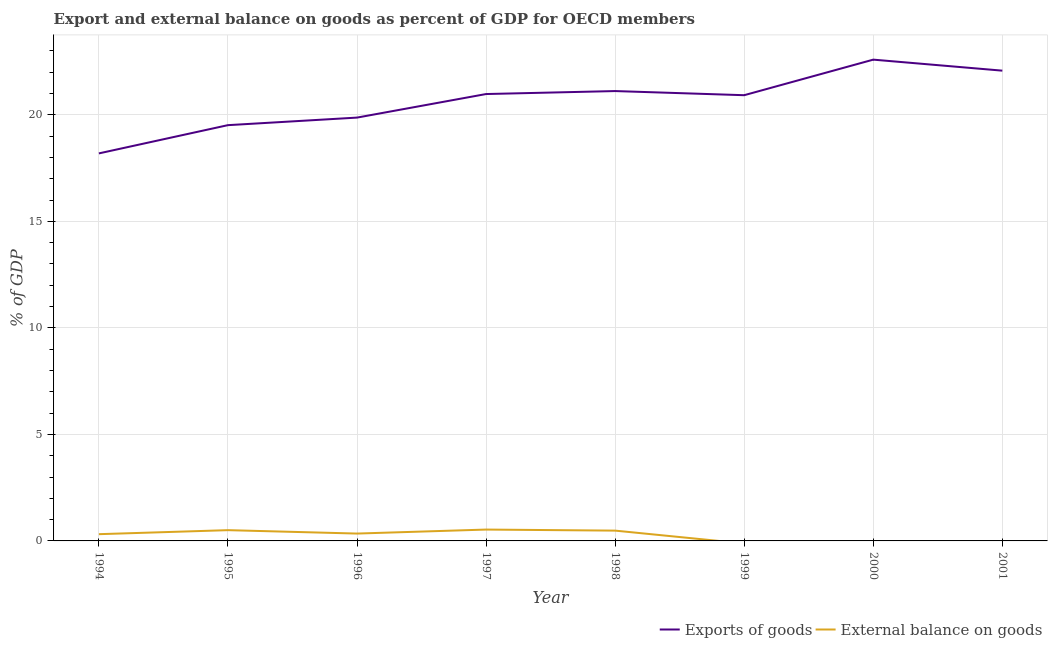What is the export of goods as percentage of gdp in 1997?
Your answer should be compact. 20.98. Across all years, what is the maximum external balance on goods as percentage of gdp?
Keep it short and to the point. 0.53. Across all years, what is the minimum external balance on goods as percentage of gdp?
Ensure brevity in your answer.  0. What is the total external balance on goods as percentage of gdp in the graph?
Offer a terse response. 2.18. What is the difference between the external balance on goods as percentage of gdp in 1996 and that in 1997?
Ensure brevity in your answer.  -0.19. What is the difference between the external balance on goods as percentage of gdp in 1994 and the export of goods as percentage of gdp in 1997?
Your response must be concise. -20.66. What is the average export of goods as percentage of gdp per year?
Make the answer very short. 20.66. In the year 1997, what is the difference between the external balance on goods as percentage of gdp and export of goods as percentage of gdp?
Provide a succinct answer. -20.45. What is the ratio of the export of goods as percentage of gdp in 1998 to that in 2001?
Offer a very short reply. 0.96. What is the difference between the highest and the second highest export of goods as percentage of gdp?
Ensure brevity in your answer.  0.52. What is the difference between the highest and the lowest export of goods as percentage of gdp?
Give a very brief answer. 4.4. Is the sum of the export of goods as percentage of gdp in 1994 and 2001 greater than the maximum external balance on goods as percentage of gdp across all years?
Offer a very short reply. Yes. How many lines are there?
Your answer should be compact. 2. Are the values on the major ticks of Y-axis written in scientific E-notation?
Your answer should be very brief. No. Does the graph contain any zero values?
Your response must be concise. Yes. Where does the legend appear in the graph?
Offer a terse response. Bottom right. How many legend labels are there?
Offer a terse response. 2. How are the legend labels stacked?
Give a very brief answer. Horizontal. What is the title of the graph?
Offer a very short reply. Export and external balance on goods as percent of GDP for OECD members. What is the label or title of the Y-axis?
Your response must be concise. % of GDP. What is the % of GDP in Exports of goods in 1994?
Give a very brief answer. 18.19. What is the % of GDP of External balance on goods in 1994?
Your answer should be compact. 0.32. What is the % of GDP in Exports of goods in 1995?
Your answer should be very brief. 19.52. What is the % of GDP in External balance on goods in 1995?
Give a very brief answer. 0.51. What is the % of GDP of Exports of goods in 1996?
Your answer should be compact. 19.87. What is the % of GDP in External balance on goods in 1996?
Offer a terse response. 0.35. What is the % of GDP of Exports of goods in 1997?
Your answer should be compact. 20.98. What is the % of GDP of External balance on goods in 1997?
Provide a short and direct response. 0.53. What is the % of GDP of Exports of goods in 1998?
Give a very brief answer. 21.12. What is the % of GDP in External balance on goods in 1998?
Your answer should be very brief. 0.48. What is the % of GDP of Exports of goods in 1999?
Provide a succinct answer. 20.92. What is the % of GDP of Exports of goods in 2000?
Your answer should be compact. 22.59. What is the % of GDP of Exports of goods in 2001?
Your response must be concise. 22.08. What is the % of GDP in External balance on goods in 2001?
Provide a succinct answer. 0. Across all years, what is the maximum % of GDP of Exports of goods?
Your answer should be very brief. 22.59. Across all years, what is the maximum % of GDP of External balance on goods?
Offer a terse response. 0.53. Across all years, what is the minimum % of GDP in Exports of goods?
Make the answer very short. 18.19. What is the total % of GDP of Exports of goods in the graph?
Your response must be concise. 165.27. What is the total % of GDP in External balance on goods in the graph?
Your answer should be very brief. 2.18. What is the difference between the % of GDP of Exports of goods in 1994 and that in 1995?
Provide a short and direct response. -1.33. What is the difference between the % of GDP in External balance on goods in 1994 and that in 1995?
Ensure brevity in your answer.  -0.19. What is the difference between the % of GDP of Exports of goods in 1994 and that in 1996?
Provide a succinct answer. -1.68. What is the difference between the % of GDP of External balance on goods in 1994 and that in 1996?
Your answer should be very brief. -0.03. What is the difference between the % of GDP in Exports of goods in 1994 and that in 1997?
Ensure brevity in your answer.  -2.79. What is the difference between the % of GDP in External balance on goods in 1994 and that in 1997?
Give a very brief answer. -0.22. What is the difference between the % of GDP of Exports of goods in 1994 and that in 1998?
Offer a very short reply. -2.93. What is the difference between the % of GDP in External balance on goods in 1994 and that in 1998?
Your response must be concise. -0.17. What is the difference between the % of GDP of Exports of goods in 1994 and that in 1999?
Provide a short and direct response. -2.73. What is the difference between the % of GDP of Exports of goods in 1994 and that in 2000?
Offer a very short reply. -4.4. What is the difference between the % of GDP of Exports of goods in 1994 and that in 2001?
Make the answer very short. -3.88. What is the difference between the % of GDP in Exports of goods in 1995 and that in 1996?
Make the answer very short. -0.35. What is the difference between the % of GDP of External balance on goods in 1995 and that in 1996?
Your response must be concise. 0.16. What is the difference between the % of GDP in Exports of goods in 1995 and that in 1997?
Your response must be concise. -1.46. What is the difference between the % of GDP in External balance on goods in 1995 and that in 1997?
Keep it short and to the point. -0.03. What is the difference between the % of GDP in Exports of goods in 1995 and that in 1998?
Your response must be concise. -1.6. What is the difference between the % of GDP of External balance on goods in 1995 and that in 1998?
Offer a very short reply. 0.02. What is the difference between the % of GDP in Exports of goods in 1995 and that in 1999?
Provide a succinct answer. -1.41. What is the difference between the % of GDP of Exports of goods in 1995 and that in 2000?
Your answer should be compact. -3.08. What is the difference between the % of GDP of Exports of goods in 1995 and that in 2001?
Give a very brief answer. -2.56. What is the difference between the % of GDP in Exports of goods in 1996 and that in 1997?
Offer a terse response. -1.11. What is the difference between the % of GDP of External balance on goods in 1996 and that in 1997?
Your answer should be very brief. -0.19. What is the difference between the % of GDP of Exports of goods in 1996 and that in 1998?
Provide a succinct answer. -1.25. What is the difference between the % of GDP of External balance on goods in 1996 and that in 1998?
Your answer should be very brief. -0.14. What is the difference between the % of GDP of Exports of goods in 1996 and that in 1999?
Your response must be concise. -1.05. What is the difference between the % of GDP of Exports of goods in 1996 and that in 2000?
Offer a very short reply. -2.72. What is the difference between the % of GDP of Exports of goods in 1996 and that in 2001?
Give a very brief answer. -2.2. What is the difference between the % of GDP of Exports of goods in 1997 and that in 1998?
Your response must be concise. -0.14. What is the difference between the % of GDP of External balance on goods in 1997 and that in 1998?
Your response must be concise. 0.05. What is the difference between the % of GDP in Exports of goods in 1997 and that in 1999?
Offer a very short reply. 0.05. What is the difference between the % of GDP of Exports of goods in 1997 and that in 2000?
Offer a very short reply. -1.61. What is the difference between the % of GDP of Exports of goods in 1997 and that in 2001?
Your response must be concise. -1.1. What is the difference between the % of GDP of Exports of goods in 1998 and that in 1999?
Ensure brevity in your answer.  0.19. What is the difference between the % of GDP of Exports of goods in 1998 and that in 2000?
Offer a very short reply. -1.47. What is the difference between the % of GDP of Exports of goods in 1998 and that in 2001?
Your answer should be very brief. -0.96. What is the difference between the % of GDP in Exports of goods in 1999 and that in 2000?
Ensure brevity in your answer.  -1.67. What is the difference between the % of GDP of Exports of goods in 1999 and that in 2001?
Offer a terse response. -1.15. What is the difference between the % of GDP of Exports of goods in 2000 and that in 2001?
Your answer should be very brief. 0.52. What is the difference between the % of GDP in Exports of goods in 1994 and the % of GDP in External balance on goods in 1995?
Your response must be concise. 17.69. What is the difference between the % of GDP of Exports of goods in 1994 and the % of GDP of External balance on goods in 1996?
Your answer should be compact. 17.85. What is the difference between the % of GDP of Exports of goods in 1994 and the % of GDP of External balance on goods in 1997?
Ensure brevity in your answer.  17.66. What is the difference between the % of GDP of Exports of goods in 1994 and the % of GDP of External balance on goods in 1998?
Keep it short and to the point. 17.71. What is the difference between the % of GDP of Exports of goods in 1995 and the % of GDP of External balance on goods in 1996?
Offer a terse response. 19.17. What is the difference between the % of GDP in Exports of goods in 1995 and the % of GDP in External balance on goods in 1997?
Keep it short and to the point. 18.98. What is the difference between the % of GDP in Exports of goods in 1995 and the % of GDP in External balance on goods in 1998?
Provide a short and direct response. 19.03. What is the difference between the % of GDP of Exports of goods in 1996 and the % of GDP of External balance on goods in 1997?
Your response must be concise. 19.34. What is the difference between the % of GDP in Exports of goods in 1996 and the % of GDP in External balance on goods in 1998?
Your response must be concise. 19.39. What is the difference between the % of GDP in Exports of goods in 1997 and the % of GDP in External balance on goods in 1998?
Give a very brief answer. 20.49. What is the average % of GDP of Exports of goods per year?
Provide a short and direct response. 20.66. What is the average % of GDP of External balance on goods per year?
Your answer should be compact. 0.27. In the year 1994, what is the difference between the % of GDP of Exports of goods and % of GDP of External balance on goods?
Offer a very short reply. 17.87. In the year 1995, what is the difference between the % of GDP in Exports of goods and % of GDP in External balance on goods?
Keep it short and to the point. 19.01. In the year 1996, what is the difference between the % of GDP of Exports of goods and % of GDP of External balance on goods?
Ensure brevity in your answer.  19.53. In the year 1997, what is the difference between the % of GDP in Exports of goods and % of GDP in External balance on goods?
Make the answer very short. 20.45. In the year 1998, what is the difference between the % of GDP in Exports of goods and % of GDP in External balance on goods?
Offer a terse response. 20.63. What is the ratio of the % of GDP of Exports of goods in 1994 to that in 1995?
Ensure brevity in your answer.  0.93. What is the ratio of the % of GDP of External balance on goods in 1994 to that in 1995?
Your response must be concise. 0.63. What is the ratio of the % of GDP of Exports of goods in 1994 to that in 1996?
Offer a terse response. 0.92. What is the ratio of the % of GDP in External balance on goods in 1994 to that in 1996?
Offer a very short reply. 0.92. What is the ratio of the % of GDP in Exports of goods in 1994 to that in 1997?
Keep it short and to the point. 0.87. What is the ratio of the % of GDP of External balance on goods in 1994 to that in 1997?
Offer a terse response. 0.59. What is the ratio of the % of GDP in Exports of goods in 1994 to that in 1998?
Give a very brief answer. 0.86. What is the ratio of the % of GDP in External balance on goods in 1994 to that in 1998?
Provide a succinct answer. 0.66. What is the ratio of the % of GDP of Exports of goods in 1994 to that in 1999?
Your answer should be very brief. 0.87. What is the ratio of the % of GDP in Exports of goods in 1994 to that in 2000?
Provide a short and direct response. 0.81. What is the ratio of the % of GDP in Exports of goods in 1994 to that in 2001?
Your response must be concise. 0.82. What is the ratio of the % of GDP of Exports of goods in 1995 to that in 1996?
Make the answer very short. 0.98. What is the ratio of the % of GDP of External balance on goods in 1995 to that in 1996?
Your response must be concise. 1.46. What is the ratio of the % of GDP in Exports of goods in 1995 to that in 1997?
Provide a short and direct response. 0.93. What is the ratio of the % of GDP of External balance on goods in 1995 to that in 1997?
Your answer should be very brief. 0.95. What is the ratio of the % of GDP in Exports of goods in 1995 to that in 1998?
Your answer should be very brief. 0.92. What is the ratio of the % of GDP in External balance on goods in 1995 to that in 1998?
Offer a very short reply. 1.04. What is the ratio of the % of GDP of Exports of goods in 1995 to that in 1999?
Give a very brief answer. 0.93. What is the ratio of the % of GDP in Exports of goods in 1995 to that in 2000?
Ensure brevity in your answer.  0.86. What is the ratio of the % of GDP of Exports of goods in 1995 to that in 2001?
Give a very brief answer. 0.88. What is the ratio of the % of GDP in Exports of goods in 1996 to that in 1997?
Offer a terse response. 0.95. What is the ratio of the % of GDP of External balance on goods in 1996 to that in 1997?
Your answer should be compact. 0.65. What is the ratio of the % of GDP of Exports of goods in 1996 to that in 1998?
Offer a very short reply. 0.94. What is the ratio of the % of GDP in Exports of goods in 1996 to that in 1999?
Keep it short and to the point. 0.95. What is the ratio of the % of GDP in Exports of goods in 1996 to that in 2000?
Offer a very short reply. 0.88. What is the ratio of the % of GDP of Exports of goods in 1996 to that in 2001?
Your answer should be very brief. 0.9. What is the ratio of the % of GDP in Exports of goods in 1997 to that in 1998?
Provide a succinct answer. 0.99. What is the ratio of the % of GDP of External balance on goods in 1997 to that in 1998?
Your answer should be compact. 1.1. What is the ratio of the % of GDP in Exports of goods in 1997 to that in 2000?
Provide a succinct answer. 0.93. What is the ratio of the % of GDP of Exports of goods in 1997 to that in 2001?
Offer a very short reply. 0.95. What is the ratio of the % of GDP in Exports of goods in 1998 to that in 1999?
Keep it short and to the point. 1.01. What is the ratio of the % of GDP in Exports of goods in 1998 to that in 2000?
Offer a very short reply. 0.93. What is the ratio of the % of GDP in Exports of goods in 1998 to that in 2001?
Keep it short and to the point. 0.96. What is the ratio of the % of GDP of Exports of goods in 1999 to that in 2000?
Provide a succinct answer. 0.93. What is the ratio of the % of GDP of Exports of goods in 1999 to that in 2001?
Your answer should be very brief. 0.95. What is the ratio of the % of GDP of Exports of goods in 2000 to that in 2001?
Offer a terse response. 1.02. What is the difference between the highest and the second highest % of GDP in Exports of goods?
Your answer should be very brief. 0.52. What is the difference between the highest and the second highest % of GDP of External balance on goods?
Your answer should be very brief. 0.03. What is the difference between the highest and the lowest % of GDP of Exports of goods?
Offer a terse response. 4.4. What is the difference between the highest and the lowest % of GDP of External balance on goods?
Provide a short and direct response. 0.53. 